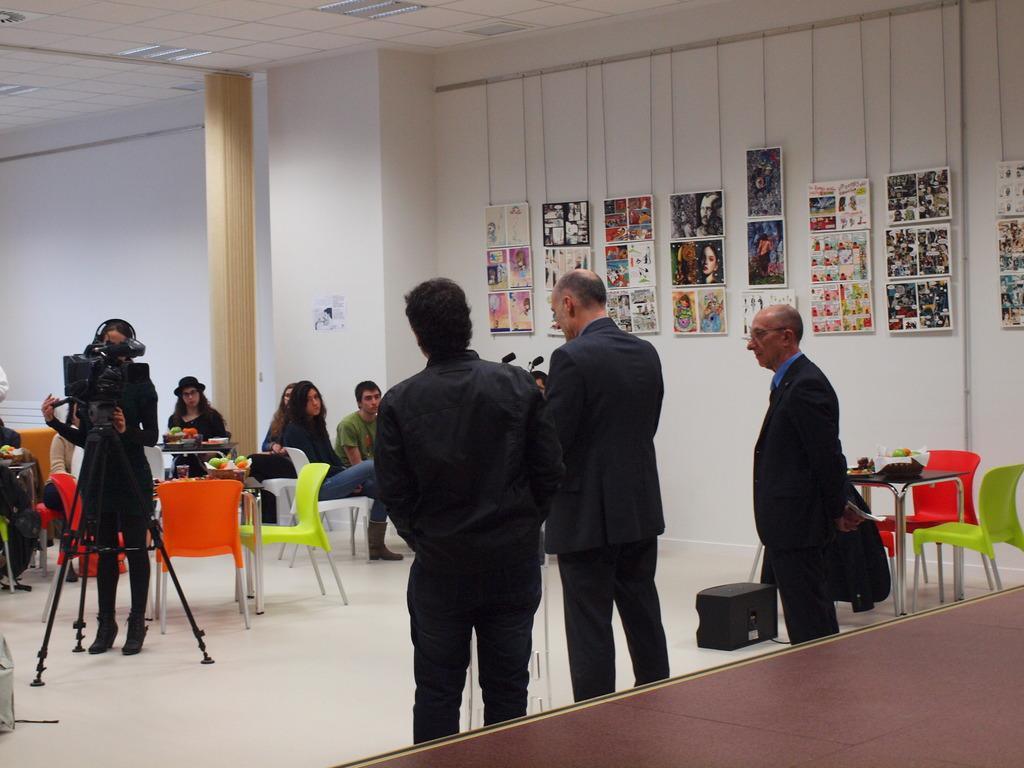How would you summarize this image in a sentence or two? In this image I can see group of people among them some are standing and some are sitting on chairs. I can also see some tables and chairs on the floor. Here I can see microphones, a person is standing beside a video camera. Here I can see a wall which are some photos on it. I can also see black color object on the floor. Here I can see lights on the ceiling and a pillar. 